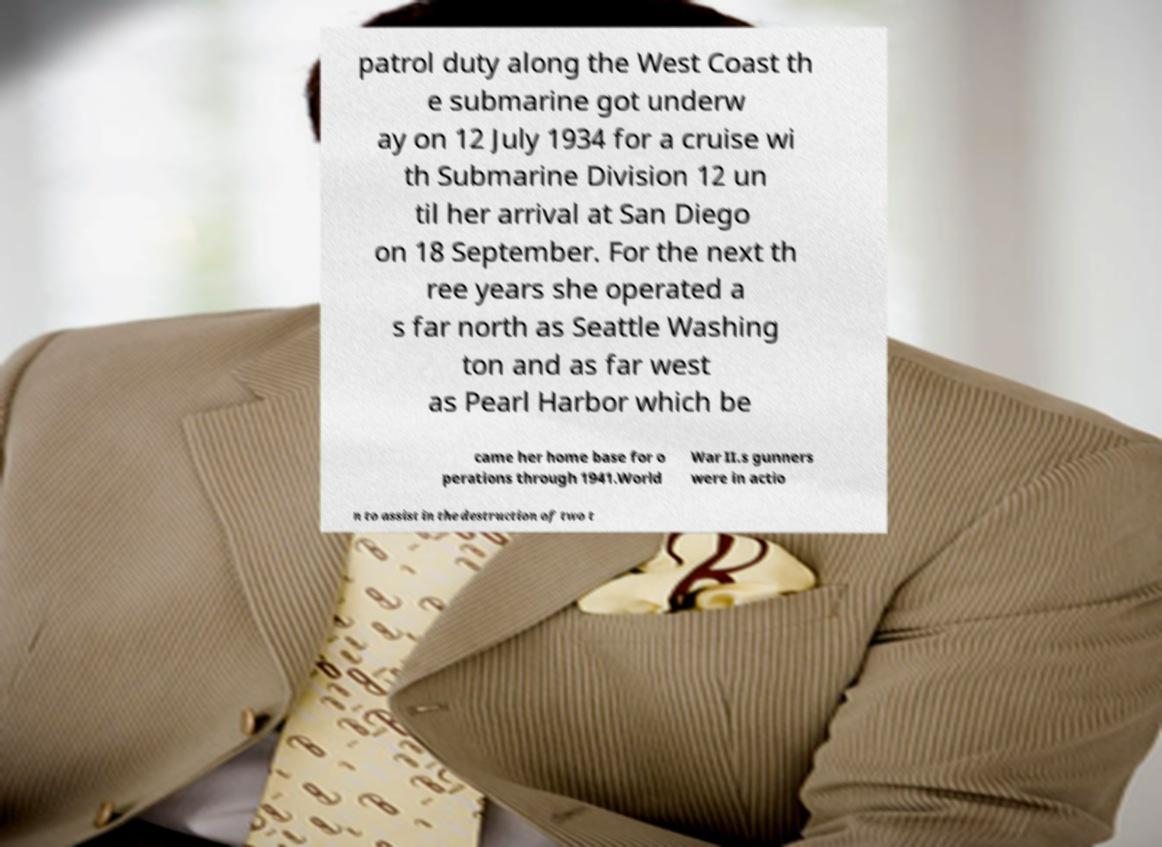Could you assist in decoding the text presented in this image and type it out clearly? patrol duty along the West Coast th e submarine got underw ay on 12 July 1934 for a cruise wi th Submarine Division 12 un til her arrival at San Diego on 18 September. For the next th ree years she operated a s far north as Seattle Washing ton and as far west as Pearl Harbor which be came her home base for o perations through 1941.World War II.s gunners were in actio n to assist in the destruction of two t 